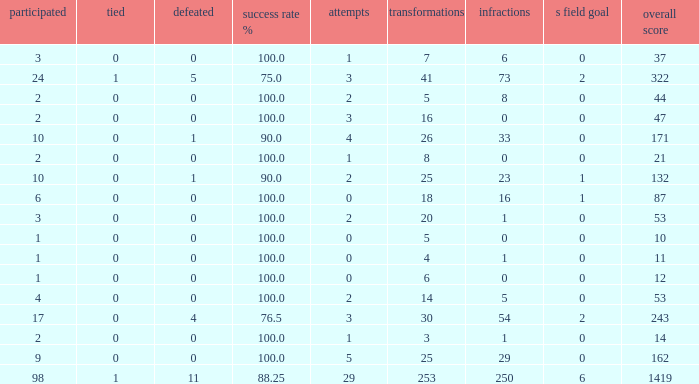How many tie units did he hold when he had 1 penalty and in excess of 20 conversions? None. 